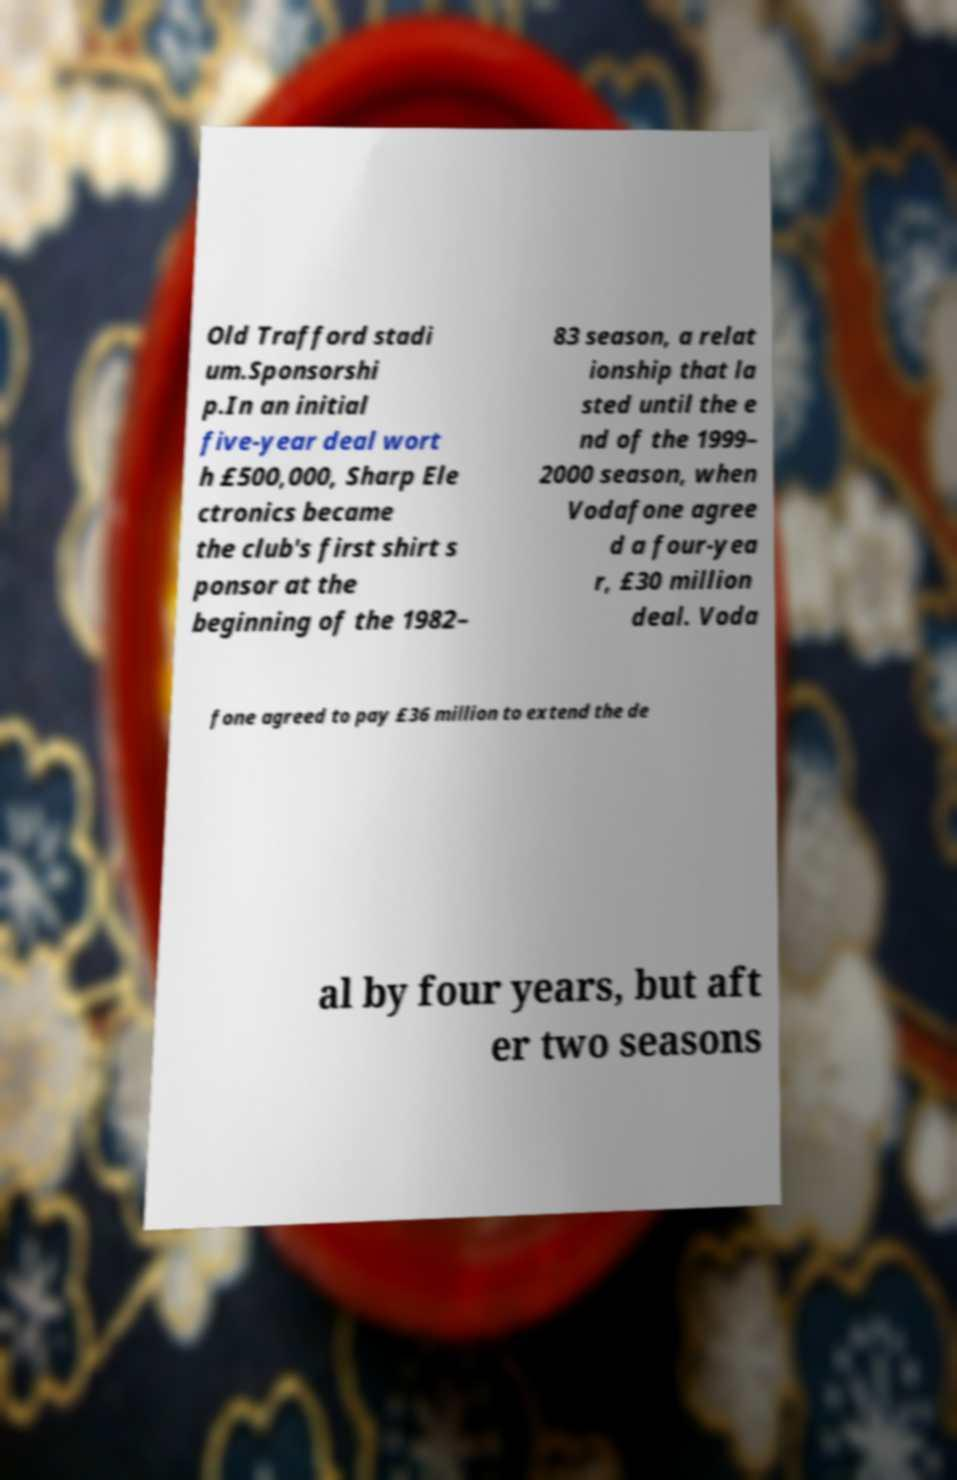Could you assist in decoding the text presented in this image and type it out clearly? Old Trafford stadi um.Sponsorshi p.In an initial five-year deal wort h £500,000, Sharp Ele ctronics became the club's first shirt s ponsor at the beginning of the 1982– 83 season, a relat ionship that la sted until the e nd of the 1999– 2000 season, when Vodafone agree d a four-yea r, £30 million deal. Voda fone agreed to pay £36 million to extend the de al by four years, but aft er two seasons 